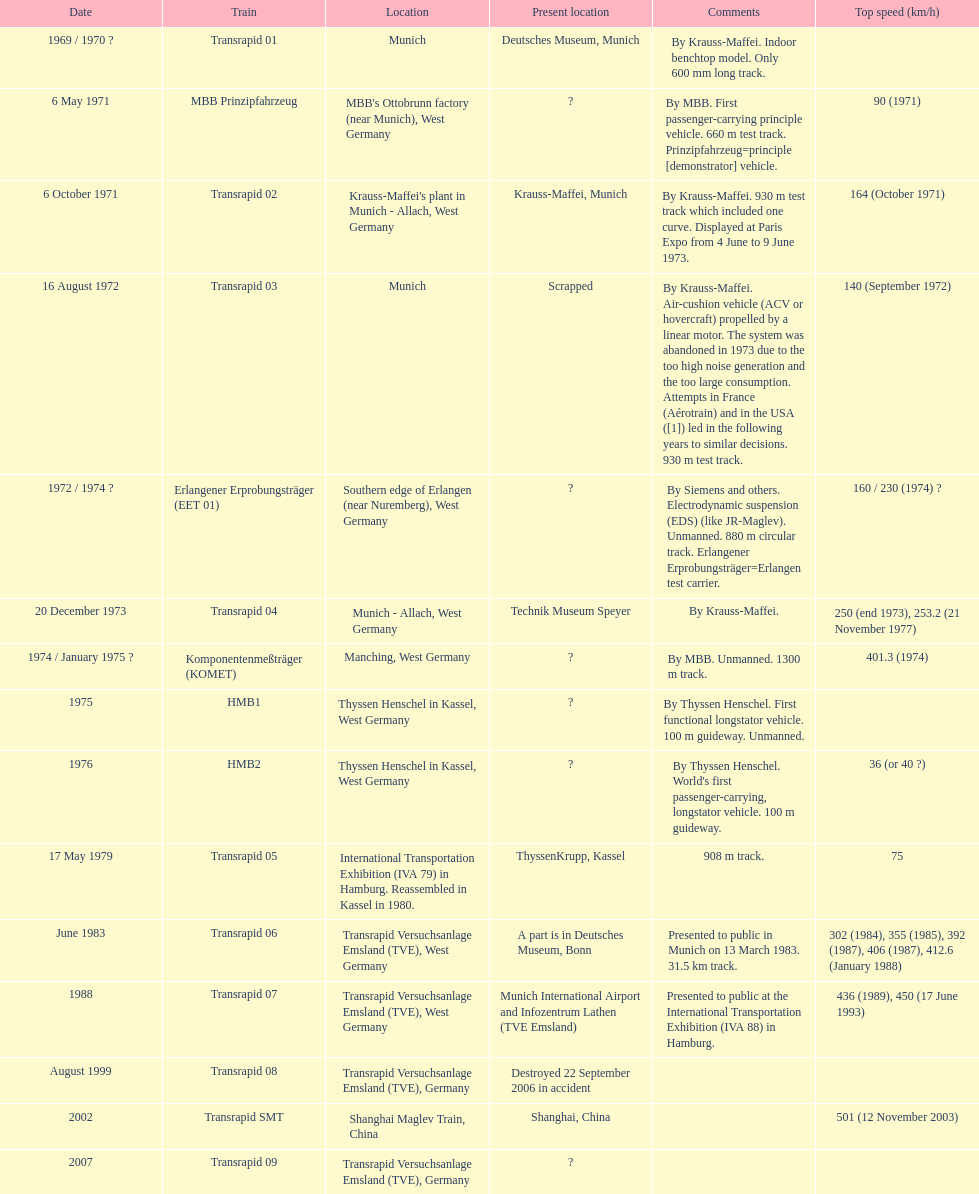Tell me the number of versions that are scrapped. 1. 